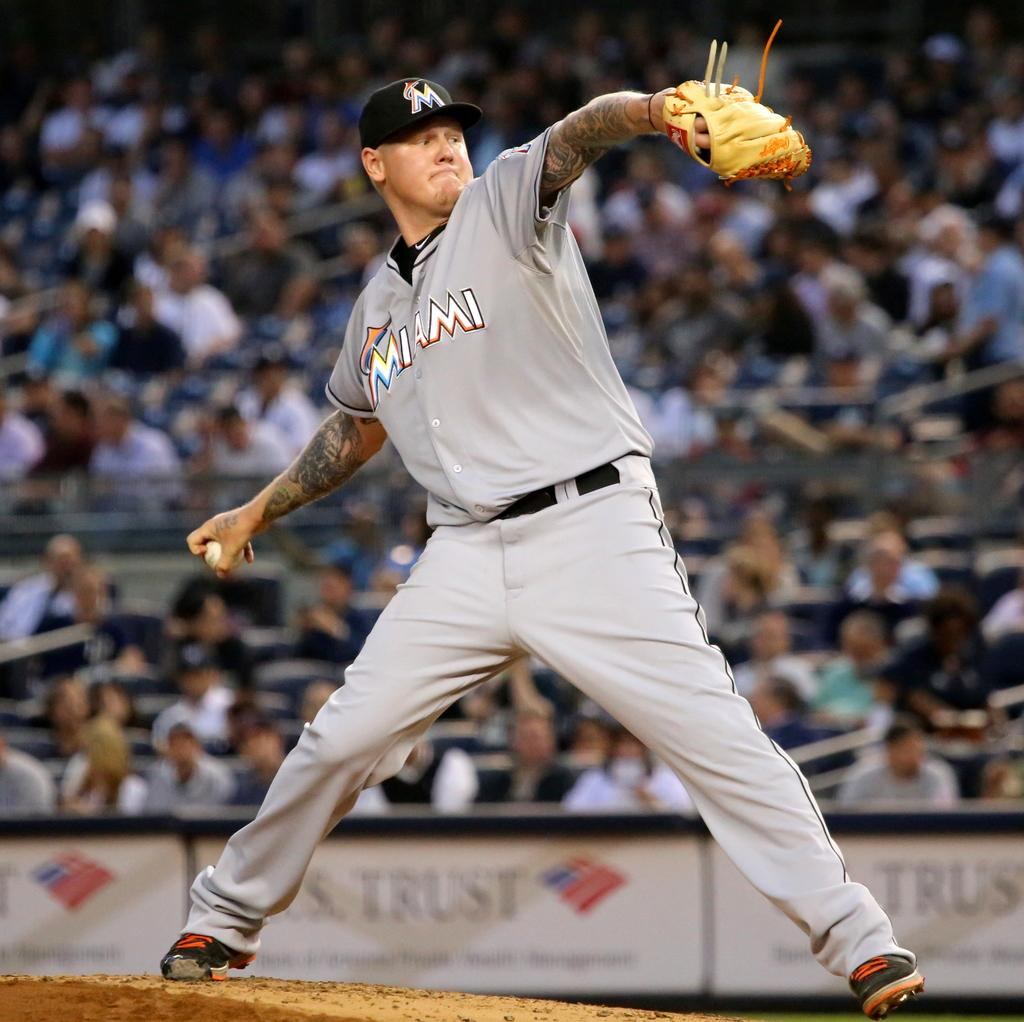<image>
Write a terse but informative summary of the picture. A pitcher for Miami winding up his pitch. 